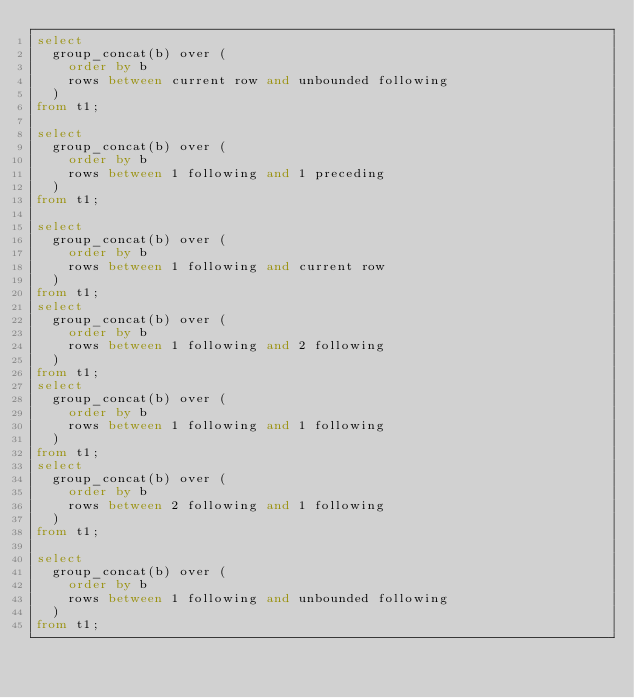Convert code to text. <code><loc_0><loc_0><loc_500><loc_500><_SQL_>select 
  group_concat(b) over (
    order by b 
    rows between current row and unbounded following
  ) 
from t1;

select 
  group_concat(b) over (
    order by b 
    rows between 1 following and 1 preceding
  ) 
from t1;

select 
  group_concat(b) over (
    order by b 
    rows between 1 following and current row
  ) 
from t1;
select 
  group_concat(b) over (
    order by b 
    rows between 1 following and 2 following
  ) 
from t1;
select 
  group_concat(b) over (
    order by b 
    rows between 1 following and 1 following
  ) 
from t1;
select 
  group_concat(b) over (
    order by b 
    rows between 2 following and 1 following
  ) 
from t1;

select 
  group_concat(b) over (
    order by b 
    rows between 1 following and unbounded following
  ) 
from t1;












</code> 